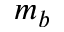<formula> <loc_0><loc_0><loc_500><loc_500>m _ { b }</formula> 